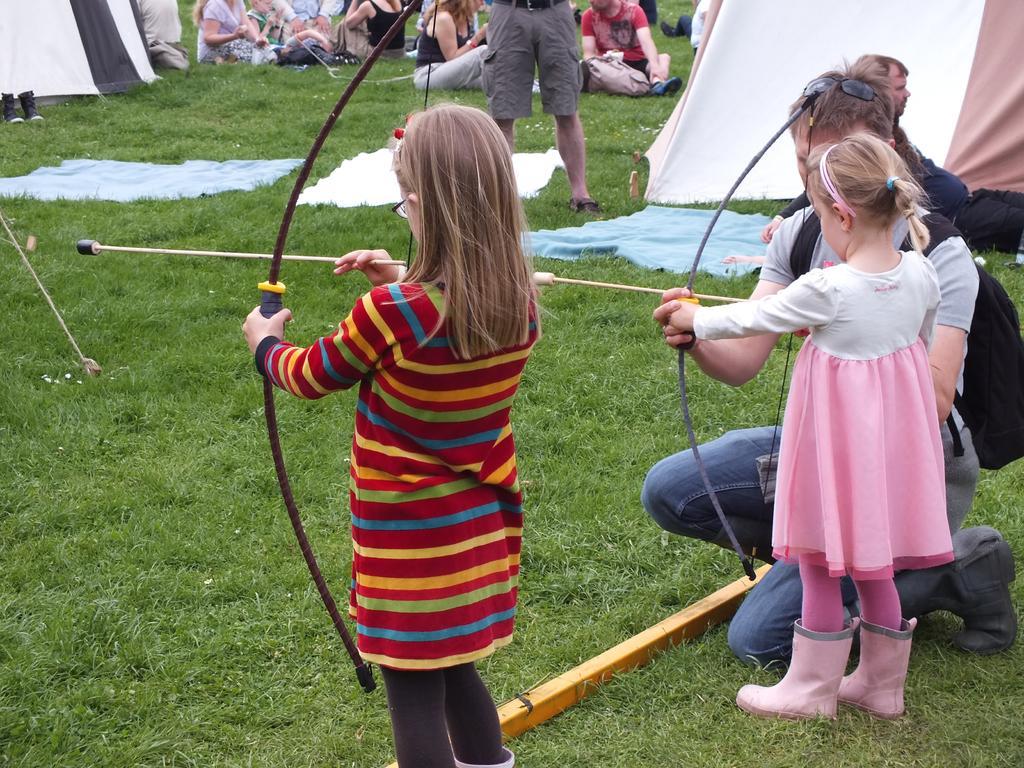Can you describe this image briefly? In this image there are a few camps and clothes are on the surface of the grass, there are two children standing and holding arrows in their hands, beside them there is a woman. In the background there are a few people standing and sitting on the grass. 